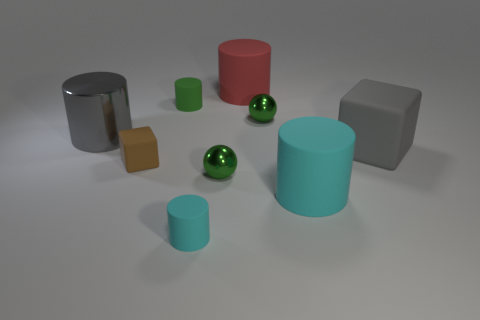Subtract 1 cylinders. How many cylinders are left? 4 Subtract all green rubber cylinders. How many cylinders are left? 4 Subtract all gray cylinders. How many cylinders are left? 4 Subtract all yellow cylinders. Subtract all cyan blocks. How many cylinders are left? 5 Subtract all cylinders. How many objects are left? 4 Add 8 green metal spheres. How many green metal spheres exist? 10 Subtract 0 purple cubes. How many objects are left? 9 Subtract all big blue matte things. Subtract all green shiny balls. How many objects are left? 7 Add 1 big cyan matte things. How many big cyan matte things are left? 2 